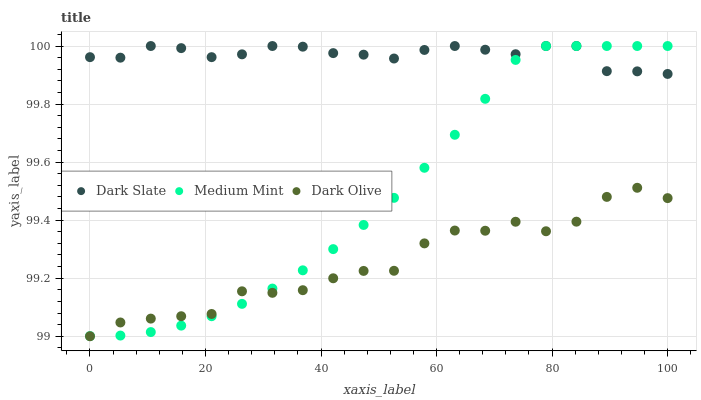Does Dark Olive have the minimum area under the curve?
Answer yes or no. Yes. Does Dark Slate have the maximum area under the curve?
Answer yes or no. Yes. Does Dark Slate have the minimum area under the curve?
Answer yes or no. No. Does Dark Olive have the maximum area under the curve?
Answer yes or no. No. Is Medium Mint the smoothest?
Answer yes or no. Yes. Is Dark Olive the roughest?
Answer yes or no. Yes. Is Dark Slate the smoothest?
Answer yes or no. No. Is Dark Slate the roughest?
Answer yes or no. No. Does Dark Olive have the lowest value?
Answer yes or no. Yes. Does Dark Slate have the lowest value?
Answer yes or no. No. Does Dark Slate have the highest value?
Answer yes or no. Yes. Does Dark Olive have the highest value?
Answer yes or no. No. Is Dark Olive less than Dark Slate?
Answer yes or no. Yes. Is Dark Slate greater than Dark Olive?
Answer yes or no. Yes. Does Medium Mint intersect Dark Slate?
Answer yes or no. Yes. Is Medium Mint less than Dark Slate?
Answer yes or no. No. Is Medium Mint greater than Dark Slate?
Answer yes or no. No. Does Dark Olive intersect Dark Slate?
Answer yes or no. No. 